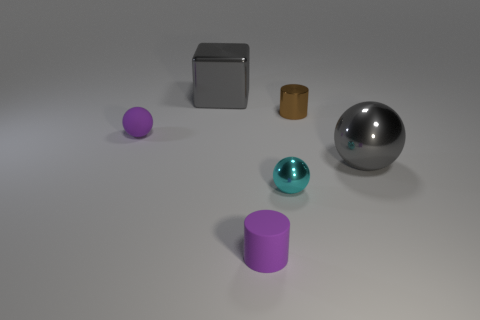Subtract all cylinders. How many objects are left? 4 Subtract 2 cylinders. How many cylinders are left? 0 Subtract all blue cylinders. Subtract all gray spheres. How many cylinders are left? 2 Subtract all brown cubes. How many purple cylinders are left? 1 Subtract all shiny cylinders. Subtract all small rubber spheres. How many objects are left? 4 Add 6 large metal objects. How many large metal objects are left? 8 Add 5 tiny cyan metallic balls. How many tiny cyan metallic balls exist? 6 Add 2 tiny cyan spheres. How many objects exist? 8 Subtract all purple balls. How many balls are left? 2 Subtract all tiny spheres. How many spheres are left? 1 